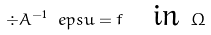<formula> <loc_0><loc_0><loc_500><loc_500>\div A ^ { - 1 } \ e p s u = f \quad \text {in } \Omega</formula> 